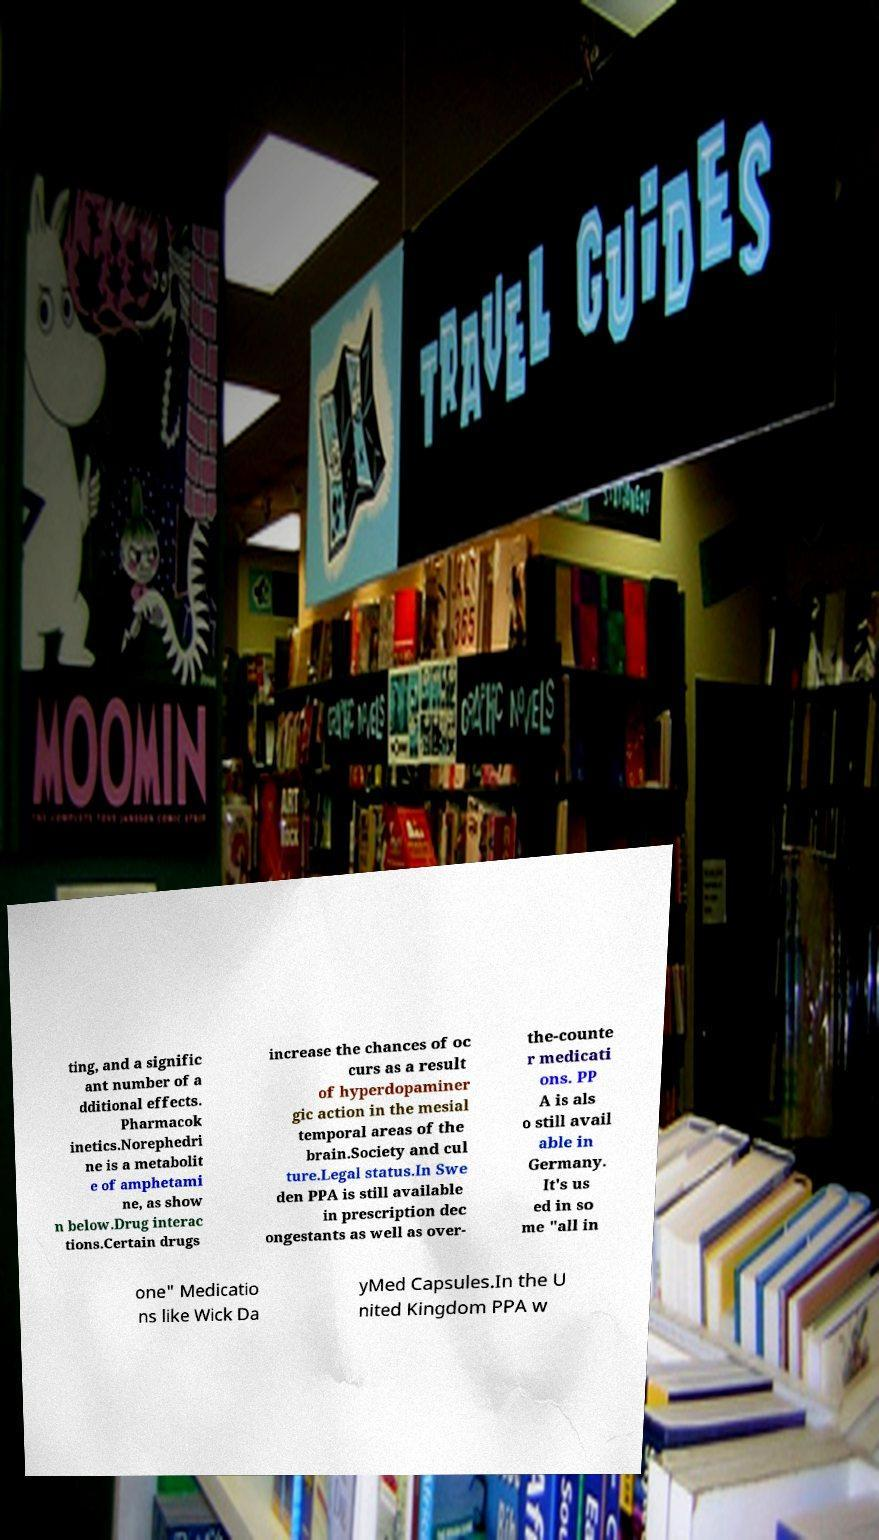Could you extract and type out the text from this image? ting, and a signific ant number of a dditional effects. Pharmacok inetics.Norephedri ne is a metabolit e of amphetami ne, as show n below.Drug interac tions.Certain drugs increase the chances of oc curs as a result of hyperdopaminer gic action in the mesial temporal areas of the brain.Society and cul ture.Legal status.In Swe den PPA is still available in prescription dec ongestants as well as over- the-counte r medicati ons. PP A is als o still avail able in Germany. It's us ed in so me "all in one" Medicatio ns like Wick Da yMed Capsules.In the U nited Kingdom PPA w 